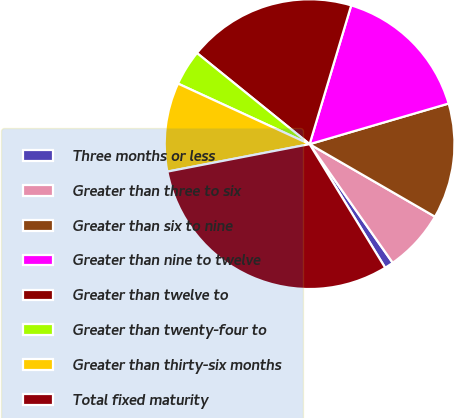Convert chart to OTSL. <chart><loc_0><loc_0><loc_500><loc_500><pie_chart><fcel>Three months or less<fcel>Greater than three to six<fcel>Greater than six to nine<fcel>Greater than nine to twelve<fcel>Greater than twelve to<fcel>Greater than twenty-four to<fcel>Greater than thirty-six months<fcel>Total fixed maturity<nl><fcel>0.99%<fcel>6.93%<fcel>12.87%<fcel>15.84%<fcel>18.81%<fcel>3.96%<fcel>9.9%<fcel>30.7%<nl></chart> 